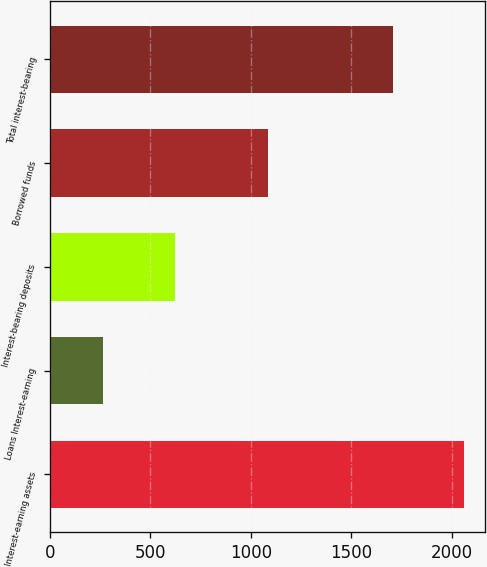Convert chart. <chart><loc_0><loc_0><loc_500><loc_500><bar_chart><fcel>Interest-earning assets<fcel>Loans Interest-earning<fcel>Interest-bearing deposits<fcel>Borrowed funds<fcel>Total interest-bearing<nl><fcel>2059<fcel>267<fcel>623<fcel>1083<fcel>1706<nl></chart> 